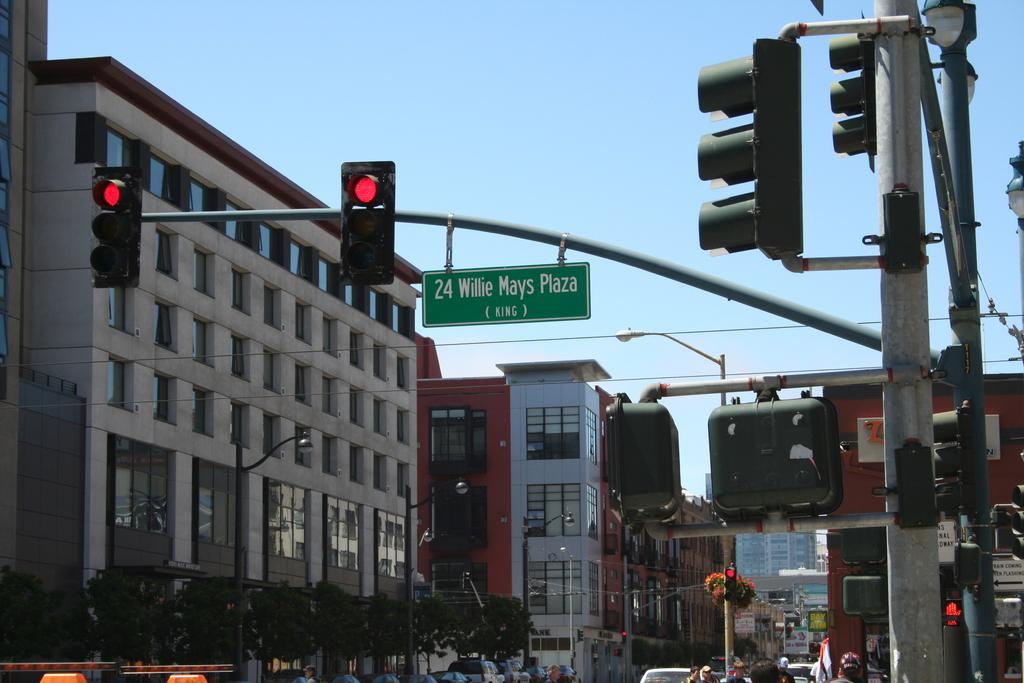<image>
Render a clear and concise summary of the photo. A traffic light with a sign under for 24 Willie Mays Plaza. 